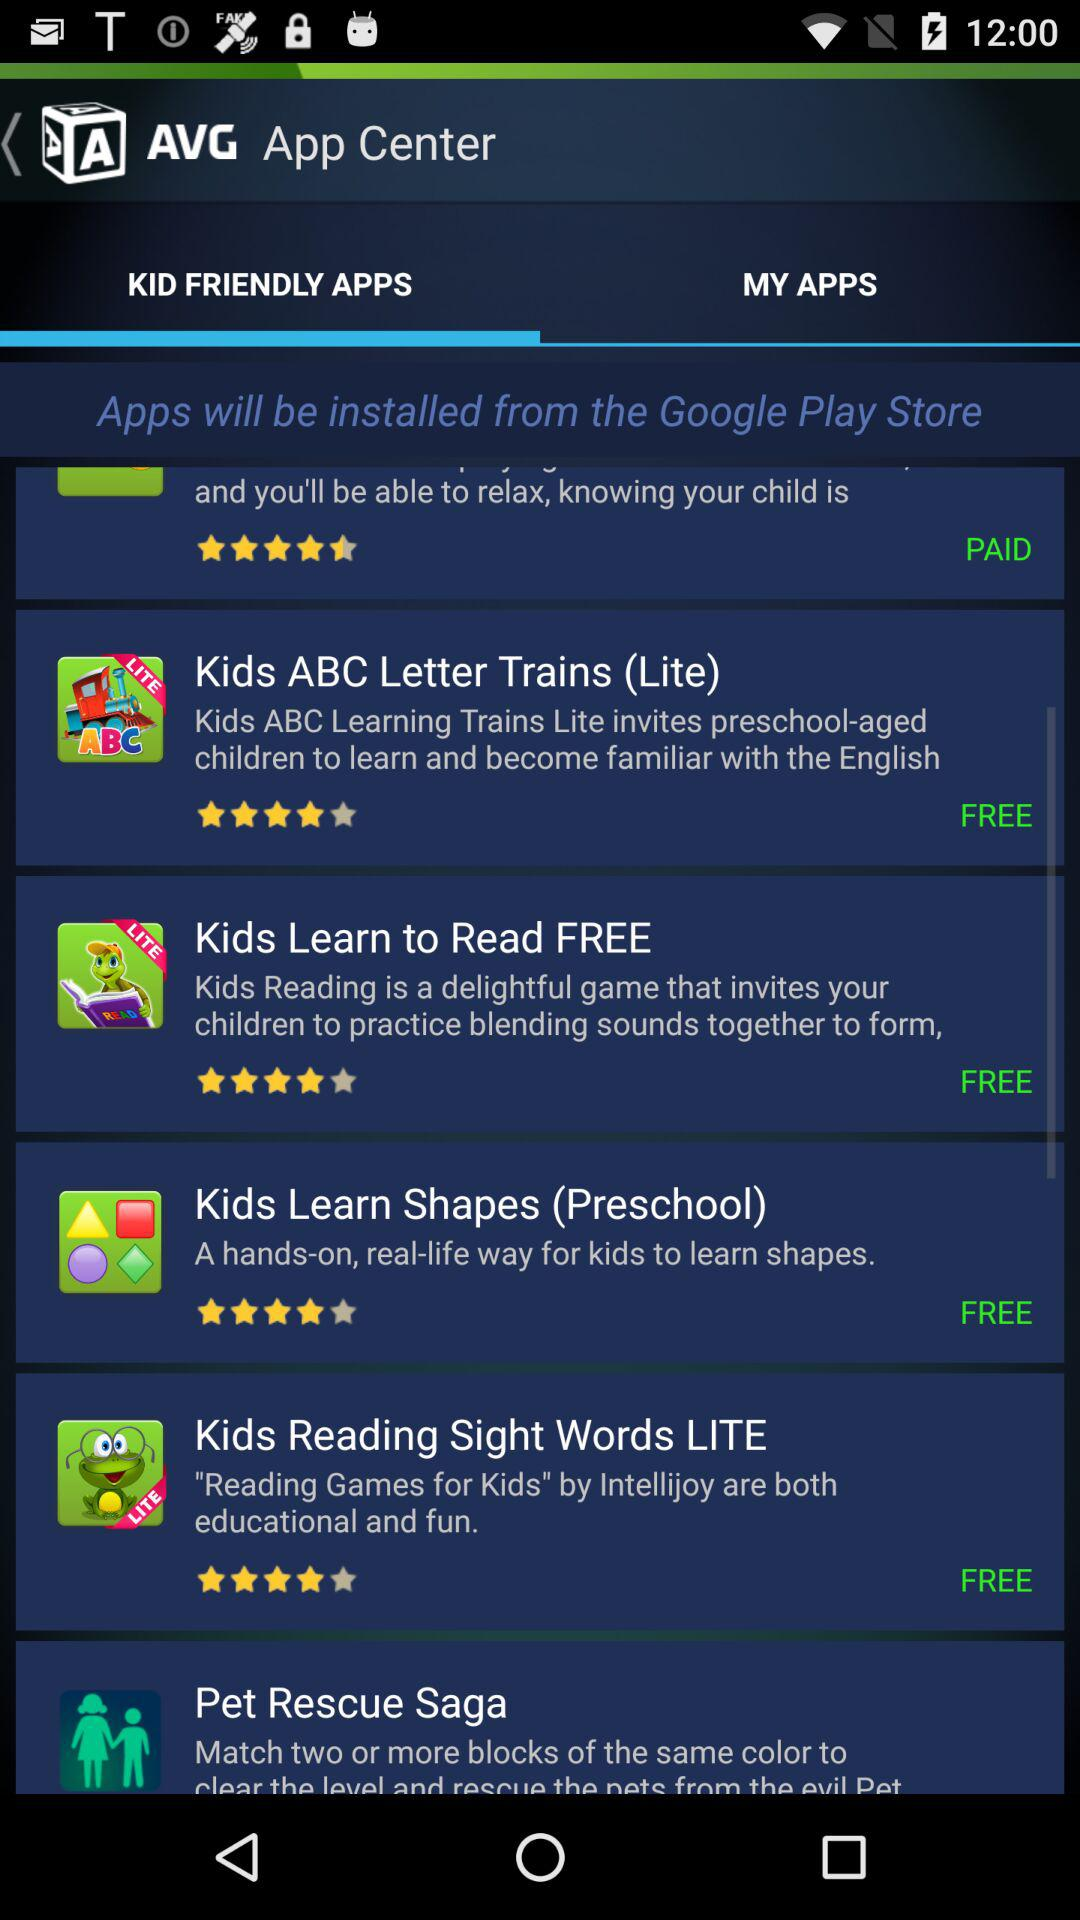What is the star rating of the application "Kids Learn to Read FREE"? The rating is 4 stars. 